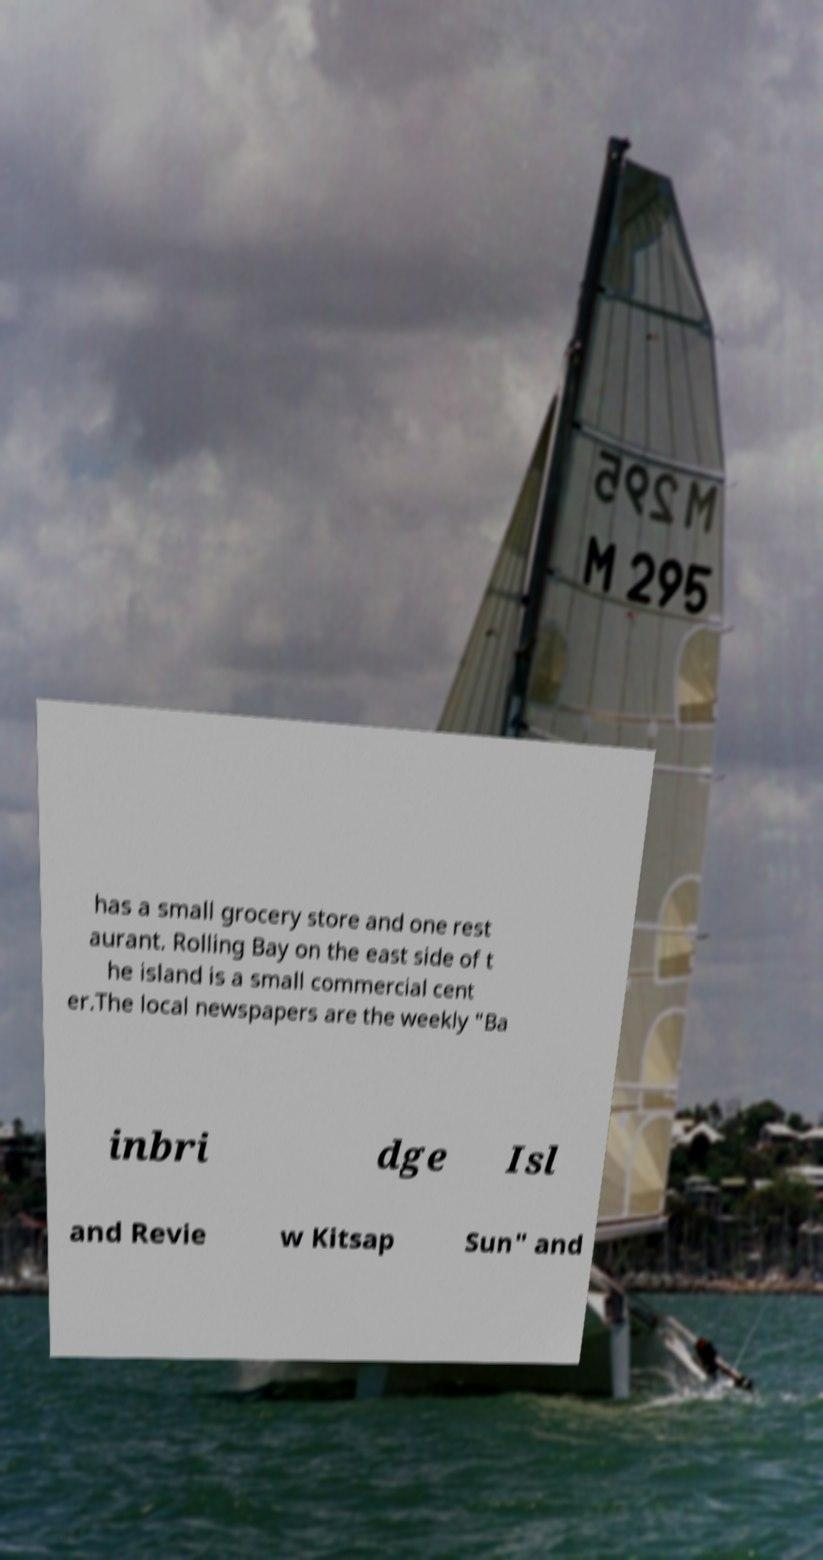There's text embedded in this image that I need extracted. Can you transcribe it verbatim? has a small grocery store and one rest aurant. Rolling Bay on the east side of t he island is a small commercial cent er.The local newspapers are the weekly "Ba inbri dge Isl and Revie w Kitsap Sun" and 